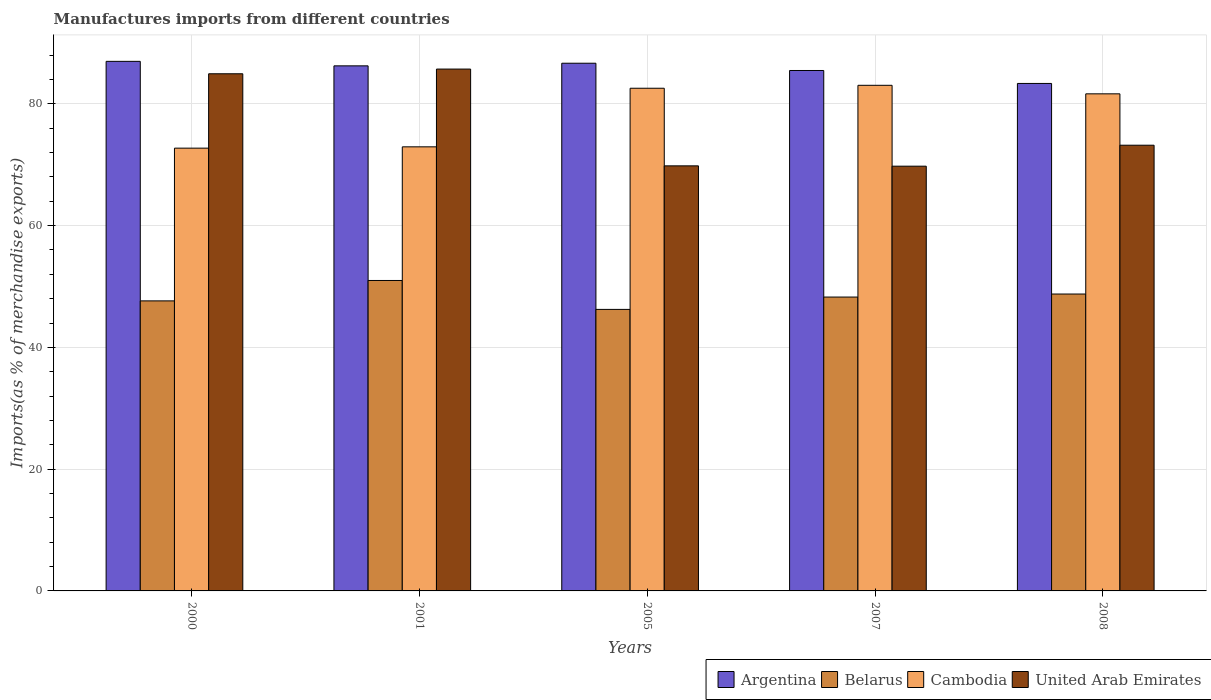How many different coloured bars are there?
Your answer should be very brief. 4. How many bars are there on the 5th tick from the left?
Keep it short and to the point. 4. What is the percentage of imports to different countries in Belarus in 2008?
Your answer should be very brief. 48.77. Across all years, what is the maximum percentage of imports to different countries in Argentina?
Your response must be concise. 86.98. Across all years, what is the minimum percentage of imports to different countries in Belarus?
Ensure brevity in your answer.  46.24. What is the total percentage of imports to different countries in Belarus in the graph?
Your answer should be compact. 241.91. What is the difference between the percentage of imports to different countries in Cambodia in 2001 and that in 2008?
Provide a succinct answer. -8.71. What is the difference between the percentage of imports to different countries in Argentina in 2000 and the percentage of imports to different countries in Cambodia in 2001?
Your response must be concise. 14.04. What is the average percentage of imports to different countries in Belarus per year?
Offer a terse response. 48.38. In the year 2001, what is the difference between the percentage of imports to different countries in Belarus and percentage of imports to different countries in United Arab Emirates?
Make the answer very short. -34.72. In how many years, is the percentage of imports to different countries in Belarus greater than 24 %?
Offer a terse response. 5. What is the ratio of the percentage of imports to different countries in Argentina in 2000 to that in 2007?
Provide a short and direct response. 1.02. What is the difference between the highest and the second highest percentage of imports to different countries in Belarus?
Provide a succinct answer. 2.23. What is the difference between the highest and the lowest percentage of imports to different countries in United Arab Emirates?
Make the answer very short. 15.95. Is it the case that in every year, the sum of the percentage of imports to different countries in Belarus and percentage of imports to different countries in United Arab Emirates is greater than the sum of percentage of imports to different countries in Cambodia and percentage of imports to different countries in Argentina?
Make the answer very short. No. What does the 4th bar from the left in 2007 represents?
Ensure brevity in your answer.  United Arab Emirates. What does the 1st bar from the right in 2000 represents?
Give a very brief answer. United Arab Emirates. How many bars are there?
Give a very brief answer. 20. Are all the bars in the graph horizontal?
Offer a very short reply. No. What is the difference between two consecutive major ticks on the Y-axis?
Make the answer very short. 20. Are the values on the major ticks of Y-axis written in scientific E-notation?
Your answer should be compact. No. Does the graph contain any zero values?
Provide a short and direct response. No. How many legend labels are there?
Provide a short and direct response. 4. How are the legend labels stacked?
Give a very brief answer. Horizontal. What is the title of the graph?
Your answer should be compact. Manufactures imports from different countries. What is the label or title of the X-axis?
Give a very brief answer. Years. What is the label or title of the Y-axis?
Provide a short and direct response. Imports(as % of merchandise exports). What is the Imports(as % of merchandise exports) of Argentina in 2000?
Give a very brief answer. 86.98. What is the Imports(as % of merchandise exports) in Belarus in 2000?
Your answer should be compact. 47.64. What is the Imports(as % of merchandise exports) in Cambodia in 2000?
Your answer should be very brief. 72.73. What is the Imports(as % of merchandise exports) in United Arab Emirates in 2000?
Ensure brevity in your answer.  84.94. What is the Imports(as % of merchandise exports) of Argentina in 2001?
Provide a short and direct response. 86.25. What is the Imports(as % of merchandise exports) in Belarus in 2001?
Your answer should be very brief. 50.99. What is the Imports(as % of merchandise exports) in Cambodia in 2001?
Offer a terse response. 72.94. What is the Imports(as % of merchandise exports) in United Arab Emirates in 2001?
Offer a terse response. 85.72. What is the Imports(as % of merchandise exports) in Argentina in 2005?
Provide a short and direct response. 86.68. What is the Imports(as % of merchandise exports) in Belarus in 2005?
Give a very brief answer. 46.24. What is the Imports(as % of merchandise exports) in Cambodia in 2005?
Keep it short and to the point. 82.57. What is the Imports(as % of merchandise exports) of United Arab Emirates in 2005?
Give a very brief answer. 69.82. What is the Imports(as % of merchandise exports) of Argentina in 2007?
Provide a short and direct response. 85.48. What is the Imports(as % of merchandise exports) of Belarus in 2007?
Offer a very short reply. 48.27. What is the Imports(as % of merchandise exports) in Cambodia in 2007?
Your answer should be compact. 83.05. What is the Imports(as % of merchandise exports) in United Arab Emirates in 2007?
Your answer should be compact. 69.77. What is the Imports(as % of merchandise exports) of Argentina in 2008?
Provide a short and direct response. 83.36. What is the Imports(as % of merchandise exports) of Belarus in 2008?
Your response must be concise. 48.77. What is the Imports(as % of merchandise exports) in Cambodia in 2008?
Ensure brevity in your answer.  81.65. What is the Imports(as % of merchandise exports) in United Arab Emirates in 2008?
Your answer should be very brief. 73.21. Across all years, what is the maximum Imports(as % of merchandise exports) of Argentina?
Offer a very short reply. 86.98. Across all years, what is the maximum Imports(as % of merchandise exports) of Belarus?
Offer a very short reply. 50.99. Across all years, what is the maximum Imports(as % of merchandise exports) in Cambodia?
Your response must be concise. 83.05. Across all years, what is the maximum Imports(as % of merchandise exports) of United Arab Emirates?
Provide a short and direct response. 85.72. Across all years, what is the minimum Imports(as % of merchandise exports) in Argentina?
Provide a succinct answer. 83.36. Across all years, what is the minimum Imports(as % of merchandise exports) of Belarus?
Offer a terse response. 46.24. Across all years, what is the minimum Imports(as % of merchandise exports) of Cambodia?
Offer a very short reply. 72.73. Across all years, what is the minimum Imports(as % of merchandise exports) in United Arab Emirates?
Your answer should be compact. 69.77. What is the total Imports(as % of merchandise exports) of Argentina in the graph?
Your answer should be compact. 428.74. What is the total Imports(as % of merchandise exports) in Belarus in the graph?
Provide a short and direct response. 241.91. What is the total Imports(as % of merchandise exports) of Cambodia in the graph?
Your answer should be compact. 392.94. What is the total Imports(as % of merchandise exports) of United Arab Emirates in the graph?
Ensure brevity in your answer.  383.45. What is the difference between the Imports(as % of merchandise exports) of Argentina in 2000 and that in 2001?
Offer a terse response. 0.74. What is the difference between the Imports(as % of merchandise exports) in Belarus in 2000 and that in 2001?
Offer a terse response. -3.35. What is the difference between the Imports(as % of merchandise exports) in Cambodia in 2000 and that in 2001?
Your response must be concise. -0.22. What is the difference between the Imports(as % of merchandise exports) in United Arab Emirates in 2000 and that in 2001?
Give a very brief answer. -0.77. What is the difference between the Imports(as % of merchandise exports) of Argentina in 2000 and that in 2005?
Your response must be concise. 0.31. What is the difference between the Imports(as % of merchandise exports) of Belarus in 2000 and that in 2005?
Give a very brief answer. 1.4. What is the difference between the Imports(as % of merchandise exports) in Cambodia in 2000 and that in 2005?
Ensure brevity in your answer.  -9.84. What is the difference between the Imports(as % of merchandise exports) in United Arab Emirates in 2000 and that in 2005?
Make the answer very short. 15.13. What is the difference between the Imports(as % of merchandise exports) in Argentina in 2000 and that in 2007?
Provide a succinct answer. 1.5. What is the difference between the Imports(as % of merchandise exports) of Belarus in 2000 and that in 2007?
Offer a terse response. -0.63. What is the difference between the Imports(as % of merchandise exports) of Cambodia in 2000 and that in 2007?
Offer a terse response. -10.32. What is the difference between the Imports(as % of merchandise exports) of United Arab Emirates in 2000 and that in 2007?
Offer a very short reply. 15.18. What is the difference between the Imports(as % of merchandise exports) in Argentina in 2000 and that in 2008?
Provide a short and direct response. 3.63. What is the difference between the Imports(as % of merchandise exports) in Belarus in 2000 and that in 2008?
Your answer should be compact. -1.13. What is the difference between the Imports(as % of merchandise exports) in Cambodia in 2000 and that in 2008?
Offer a very short reply. -8.92. What is the difference between the Imports(as % of merchandise exports) in United Arab Emirates in 2000 and that in 2008?
Offer a very short reply. 11.74. What is the difference between the Imports(as % of merchandise exports) in Argentina in 2001 and that in 2005?
Provide a succinct answer. -0.43. What is the difference between the Imports(as % of merchandise exports) of Belarus in 2001 and that in 2005?
Your answer should be compact. 4.75. What is the difference between the Imports(as % of merchandise exports) in Cambodia in 2001 and that in 2005?
Ensure brevity in your answer.  -9.62. What is the difference between the Imports(as % of merchandise exports) in United Arab Emirates in 2001 and that in 2005?
Offer a very short reply. 15.9. What is the difference between the Imports(as % of merchandise exports) in Argentina in 2001 and that in 2007?
Keep it short and to the point. 0.76. What is the difference between the Imports(as % of merchandise exports) in Belarus in 2001 and that in 2007?
Offer a very short reply. 2.73. What is the difference between the Imports(as % of merchandise exports) of Cambodia in 2001 and that in 2007?
Make the answer very short. -10.11. What is the difference between the Imports(as % of merchandise exports) in United Arab Emirates in 2001 and that in 2007?
Ensure brevity in your answer.  15.95. What is the difference between the Imports(as % of merchandise exports) of Argentina in 2001 and that in 2008?
Make the answer very short. 2.89. What is the difference between the Imports(as % of merchandise exports) in Belarus in 2001 and that in 2008?
Offer a very short reply. 2.23. What is the difference between the Imports(as % of merchandise exports) in Cambodia in 2001 and that in 2008?
Your response must be concise. -8.71. What is the difference between the Imports(as % of merchandise exports) in United Arab Emirates in 2001 and that in 2008?
Provide a short and direct response. 12.51. What is the difference between the Imports(as % of merchandise exports) of Argentina in 2005 and that in 2007?
Your response must be concise. 1.19. What is the difference between the Imports(as % of merchandise exports) of Belarus in 2005 and that in 2007?
Your response must be concise. -2.03. What is the difference between the Imports(as % of merchandise exports) in Cambodia in 2005 and that in 2007?
Make the answer very short. -0.48. What is the difference between the Imports(as % of merchandise exports) in United Arab Emirates in 2005 and that in 2007?
Ensure brevity in your answer.  0.05. What is the difference between the Imports(as % of merchandise exports) in Argentina in 2005 and that in 2008?
Your answer should be very brief. 3.32. What is the difference between the Imports(as % of merchandise exports) of Belarus in 2005 and that in 2008?
Give a very brief answer. -2.53. What is the difference between the Imports(as % of merchandise exports) in Cambodia in 2005 and that in 2008?
Provide a short and direct response. 0.92. What is the difference between the Imports(as % of merchandise exports) of United Arab Emirates in 2005 and that in 2008?
Offer a very short reply. -3.39. What is the difference between the Imports(as % of merchandise exports) in Argentina in 2007 and that in 2008?
Your answer should be compact. 2.13. What is the difference between the Imports(as % of merchandise exports) of Belarus in 2007 and that in 2008?
Keep it short and to the point. -0.5. What is the difference between the Imports(as % of merchandise exports) of Cambodia in 2007 and that in 2008?
Give a very brief answer. 1.4. What is the difference between the Imports(as % of merchandise exports) of United Arab Emirates in 2007 and that in 2008?
Offer a terse response. -3.44. What is the difference between the Imports(as % of merchandise exports) in Argentina in 2000 and the Imports(as % of merchandise exports) in Belarus in 2001?
Provide a short and direct response. 35.99. What is the difference between the Imports(as % of merchandise exports) of Argentina in 2000 and the Imports(as % of merchandise exports) of Cambodia in 2001?
Your answer should be very brief. 14.04. What is the difference between the Imports(as % of merchandise exports) of Argentina in 2000 and the Imports(as % of merchandise exports) of United Arab Emirates in 2001?
Keep it short and to the point. 1.27. What is the difference between the Imports(as % of merchandise exports) of Belarus in 2000 and the Imports(as % of merchandise exports) of Cambodia in 2001?
Provide a short and direct response. -25.3. What is the difference between the Imports(as % of merchandise exports) of Belarus in 2000 and the Imports(as % of merchandise exports) of United Arab Emirates in 2001?
Make the answer very short. -38.07. What is the difference between the Imports(as % of merchandise exports) of Cambodia in 2000 and the Imports(as % of merchandise exports) of United Arab Emirates in 2001?
Offer a very short reply. -12.99. What is the difference between the Imports(as % of merchandise exports) of Argentina in 2000 and the Imports(as % of merchandise exports) of Belarus in 2005?
Provide a short and direct response. 40.74. What is the difference between the Imports(as % of merchandise exports) of Argentina in 2000 and the Imports(as % of merchandise exports) of Cambodia in 2005?
Give a very brief answer. 4.42. What is the difference between the Imports(as % of merchandise exports) of Argentina in 2000 and the Imports(as % of merchandise exports) of United Arab Emirates in 2005?
Your response must be concise. 17.16. What is the difference between the Imports(as % of merchandise exports) of Belarus in 2000 and the Imports(as % of merchandise exports) of Cambodia in 2005?
Provide a succinct answer. -34.93. What is the difference between the Imports(as % of merchandise exports) of Belarus in 2000 and the Imports(as % of merchandise exports) of United Arab Emirates in 2005?
Offer a terse response. -22.18. What is the difference between the Imports(as % of merchandise exports) of Cambodia in 2000 and the Imports(as % of merchandise exports) of United Arab Emirates in 2005?
Your answer should be very brief. 2.91. What is the difference between the Imports(as % of merchandise exports) of Argentina in 2000 and the Imports(as % of merchandise exports) of Belarus in 2007?
Make the answer very short. 38.72. What is the difference between the Imports(as % of merchandise exports) in Argentina in 2000 and the Imports(as % of merchandise exports) in Cambodia in 2007?
Your answer should be very brief. 3.93. What is the difference between the Imports(as % of merchandise exports) of Argentina in 2000 and the Imports(as % of merchandise exports) of United Arab Emirates in 2007?
Keep it short and to the point. 17.22. What is the difference between the Imports(as % of merchandise exports) in Belarus in 2000 and the Imports(as % of merchandise exports) in Cambodia in 2007?
Provide a short and direct response. -35.41. What is the difference between the Imports(as % of merchandise exports) in Belarus in 2000 and the Imports(as % of merchandise exports) in United Arab Emirates in 2007?
Your answer should be compact. -22.12. What is the difference between the Imports(as % of merchandise exports) of Cambodia in 2000 and the Imports(as % of merchandise exports) of United Arab Emirates in 2007?
Provide a succinct answer. 2.96. What is the difference between the Imports(as % of merchandise exports) in Argentina in 2000 and the Imports(as % of merchandise exports) in Belarus in 2008?
Your answer should be very brief. 38.22. What is the difference between the Imports(as % of merchandise exports) in Argentina in 2000 and the Imports(as % of merchandise exports) in Cambodia in 2008?
Your answer should be very brief. 5.33. What is the difference between the Imports(as % of merchandise exports) in Argentina in 2000 and the Imports(as % of merchandise exports) in United Arab Emirates in 2008?
Give a very brief answer. 13.78. What is the difference between the Imports(as % of merchandise exports) in Belarus in 2000 and the Imports(as % of merchandise exports) in Cambodia in 2008?
Ensure brevity in your answer.  -34.01. What is the difference between the Imports(as % of merchandise exports) of Belarus in 2000 and the Imports(as % of merchandise exports) of United Arab Emirates in 2008?
Offer a terse response. -25.57. What is the difference between the Imports(as % of merchandise exports) in Cambodia in 2000 and the Imports(as % of merchandise exports) in United Arab Emirates in 2008?
Your answer should be very brief. -0.48. What is the difference between the Imports(as % of merchandise exports) in Argentina in 2001 and the Imports(as % of merchandise exports) in Belarus in 2005?
Keep it short and to the point. 40. What is the difference between the Imports(as % of merchandise exports) of Argentina in 2001 and the Imports(as % of merchandise exports) of Cambodia in 2005?
Your answer should be very brief. 3.68. What is the difference between the Imports(as % of merchandise exports) in Argentina in 2001 and the Imports(as % of merchandise exports) in United Arab Emirates in 2005?
Your response must be concise. 16.43. What is the difference between the Imports(as % of merchandise exports) in Belarus in 2001 and the Imports(as % of merchandise exports) in Cambodia in 2005?
Offer a terse response. -31.57. What is the difference between the Imports(as % of merchandise exports) of Belarus in 2001 and the Imports(as % of merchandise exports) of United Arab Emirates in 2005?
Make the answer very short. -18.83. What is the difference between the Imports(as % of merchandise exports) in Cambodia in 2001 and the Imports(as % of merchandise exports) in United Arab Emirates in 2005?
Your answer should be compact. 3.12. What is the difference between the Imports(as % of merchandise exports) in Argentina in 2001 and the Imports(as % of merchandise exports) in Belarus in 2007?
Make the answer very short. 37.98. What is the difference between the Imports(as % of merchandise exports) of Argentina in 2001 and the Imports(as % of merchandise exports) of Cambodia in 2007?
Your response must be concise. 3.2. What is the difference between the Imports(as % of merchandise exports) of Argentina in 2001 and the Imports(as % of merchandise exports) of United Arab Emirates in 2007?
Make the answer very short. 16.48. What is the difference between the Imports(as % of merchandise exports) in Belarus in 2001 and the Imports(as % of merchandise exports) in Cambodia in 2007?
Offer a terse response. -32.06. What is the difference between the Imports(as % of merchandise exports) of Belarus in 2001 and the Imports(as % of merchandise exports) of United Arab Emirates in 2007?
Offer a terse response. -18.77. What is the difference between the Imports(as % of merchandise exports) of Cambodia in 2001 and the Imports(as % of merchandise exports) of United Arab Emirates in 2007?
Provide a short and direct response. 3.18. What is the difference between the Imports(as % of merchandise exports) of Argentina in 2001 and the Imports(as % of merchandise exports) of Belarus in 2008?
Provide a succinct answer. 37.48. What is the difference between the Imports(as % of merchandise exports) of Argentina in 2001 and the Imports(as % of merchandise exports) of Cambodia in 2008?
Make the answer very short. 4.6. What is the difference between the Imports(as % of merchandise exports) in Argentina in 2001 and the Imports(as % of merchandise exports) in United Arab Emirates in 2008?
Your answer should be very brief. 13.04. What is the difference between the Imports(as % of merchandise exports) of Belarus in 2001 and the Imports(as % of merchandise exports) of Cambodia in 2008?
Your response must be concise. -30.66. What is the difference between the Imports(as % of merchandise exports) in Belarus in 2001 and the Imports(as % of merchandise exports) in United Arab Emirates in 2008?
Keep it short and to the point. -22.22. What is the difference between the Imports(as % of merchandise exports) in Cambodia in 2001 and the Imports(as % of merchandise exports) in United Arab Emirates in 2008?
Your answer should be very brief. -0.27. What is the difference between the Imports(as % of merchandise exports) of Argentina in 2005 and the Imports(as % of merchandise exports) of Belarus in 2007?
Your answer should be compact. 38.41. What is the difference between the Imports(as % of merchandise exports) in Argentina in 2005 and the Imports(as % of merchandise exports) in Cambodia in 2007?
Your answer should be very brief. 3.62. What is the difference between the Imports(as % of merchandise exports) in Argentina in 2005 and the Imports(as % of merchandise exports) in United Arab Emirates in 2007?
Ensure brevity in your answer.  16.91. What is the difference between the Imports(as % of merchandise exports) of Belarus in 2005 and the Imports(as % of merchandise exports) of Cambodia in 2007?
Your answer should be very brief. -36.81. What is the difference between the Imports(as % of merchandise exports) in Belarus in 2005 and the Imports(as % of merchandise exports) in United Arab Emirates in 2007?
Your answer should be compact. -23.53. What is the difference between the Imports(as % of merchandise exports) in Cambodia in 2005 and the Imports(as % of merchandise exports) in United Arab Emirates in 2007?
Give a very brief answer. 12.8. What is the difference between the Imports(as % of merchandise exports) in Argentina in 2005 and the Imports(as % of merchandise exports) in Belarus in 2008?
Keep it short and to the point. 37.91. What is the difference between the Imports(as % of merchandise exports) of Argentina in 2005 and the Imports(as % of merchandise exports) of Cambodia in 2008?
Your answer should be compact. 5.03. What is the difference between the Imports(as % of merchandise exports) of Argentina in 2005 and the Imports(as % of merchandise exports) of United Arab Emirates in 2008?
Ensure brevity in your answer.  13.47. What is the difference between the Imports(as % of merchandise exports) in Belarus in 2005 and the Imports(as % of merchandise exports) in Cambodia in 2008?
Provide a short and direct response. -35.41. What is the difference between the Imports(as % of merchandise exports) in Belarus in 2005 and the Imports(as % of merchandise exports) in United Arab Emirates in 2008?
Your response must be concise. -26.97. What is the difference between the Imports(as % of merchandise exports) of Cambodia in 2005 and the Imports(as % of merchandise exports) of United Arab Emirates in 2008?
Provide a succinct answer. 9.36. What is the difference between the Imports(as % of merchandise exports) in Argentina in 2007 and the Imports(as % of merchandise exports) in Belarus in 2008?
Your answer should be compact. 36.72. What is the difference between the Imports(as % of merchandise exports) of Argentina in 2007 and the Imports(as % of merchandise exports) of Cambodia in 2008?
Make the answer very short. 3.83. What is the difference between the Imports(as % of merchandise exports) in Argentina in 2007 and the Imports(as % of merchandise exports) in United Arab Emirates in 2008?
Make the answer very short. 12.27. What is the difference between the Imports(as % of merchandise exports) of Belarus in 2007 and the Imports(as % of merchandise exports) of Cambodia in 2008?
Offer a terse response. -33.38. What is the difference between the Imports(as % of merchandise exports) of Belarus in 2007 and the Imports(as % of merchandise exports) of United Arab Emirates in 2008?
Offer a very short reply. -24.94. What is the difference between the Imports(as % of merchandise exports) in Cambodia in 2007 and the Imports(as % of merchandise exports) in United Arab Emirates in 2008?
Keep it short and to the point. 9.84. What is the average Imports(as % of merchandise exports) of Argentina per year?
Provide a succinct answer. 85.75. What is the average Imports(as % of merchandise exports) in Belarus per year?
Your answer should be compact. 48.38. What is the average Imports(as % of merchandise exports) of Cambodia per year?
Provide a succinct answer. 78.59. What is the average Imports(as % of merchandise exports) of United Arab Emirates per year?
Ensure brevity in your answer.  76.69. In the year 2000, what is the difference between the Imports(as % of merchandise exports) of Argentina and Imports(as % of merchandise exports) of Belarus?
Keep it short and to the point. 39.34. In the year 2000, what is the difference between the Imports(as % of merchandise exports) in Argentina and Imports(as % of merchandise exports) in Cambodia?
Offer a very short reply. 14.26. In the year 2000, what is the difference between the Imports(as % of merchandise exports) in Argentina and Imports(as % of merchandise exports) in United Arab Emirates?
Keep it short and to the point. 2.04. In the year 2000, what is the difference between the Imports(as % of merchandise exports) of Belarus and Imports(as % of merchandise exports) of Cambodia?
Provide a succinct answer. -25.09. In the year 2000, what is the difference between the Imports(as % of merchandise exports) in Belarus and Imports(as % of merchandise exports) in United Arab Emirates?
Make the answer very short. -37.3. In the year 2000, what is the difference between the Imports(as % of merchandise exports) of Cambodia and Imports(as % of merchandise exports) of United Arab Emirates?
Ensure brevity in your answer.  -12.22. In the year 2001, what is the difference between the Imports(as % of merchandise exports) in Argentina and Imports(as % of merchandise exports) in Belarus?
Your answer should be compact. 35.25. In the year 2001, what is the difference between the Imports(as % of merchandise exports) of Argentina and Imports(as % of merchandise exports) of Cambodia?
Your answer should be compact. 13.3. In the year 2001, what is the difference between the Imports(as % of merchandise exports) in Argentina and Imports(as % of merchandise exports) in United Arab Emirates?
Your answer should be very brief. 0.53. In the year 2001, what is the difference between the Imports(as % of merchandise exports) of Belarus and Imports(as % of merchandise exports) of Cambodia?
Keep it short and to the point. -21.95. In the year 2001, what is the difference between the Imports(as % of merchandise exports) in Belarus and Imports(as % of merchandise exports) in United Arab Emirates?
Your answer should be compact. -34.72. In the year 2001, what is the difference between the Imports(as % of merchandise exports) in Cambodia and Imports(as % of merchandise exports) in United Arab Emirates?
Your answer should be compact. -12.77. In the year 2005, what is the difference between the Imports(as % of merchandise exports) of Argentina and Imports(as % of merchandise exports) of Belarus?
Your response must be concise. 40.43. In the year 2005, what is the difference between the Imports(as % of merchandise exports) of Argentina and Imports(as % of merchandise exports) of Cambodia?
Offer a terse response. 4.11. In the year 2005, what is the difference between the Imports(as % of merchandise exports) of Argentina and Imports(as % of merchandise exports) of United Arab Emirates?
Your response must be concise. 16.86. In the year 2005, what is the difference between the Imports(as % of merchandise exports) of Belarus and Imports(as % of merchandise exports) of Cambodia?
Ensure brevity in your answer.  -36.33. In the year 2005, what is the difference between the Imports(as % of merchandise exports) of Belarus and Imports(as % of merchandise exports) of United Arab Emirates?
Provide a short and direct response. -23.58. In the year 2005, what is the difference between the Imports(as % of merchandise exports) of Cambodia and Imports(as % of merchandise exports) of United Arab Emirates?
Your answer should be compact. 12.75. In the year 2007, what is the difference between the Imports(as % of merchandise exports) in Argentina and Imports(as % of merchandise exports) in Belarus?
Provide a succinct answer. 37.22. In the year 2007, what is the difference between the Imports(as % of merchandise exports) in Argentina and Imports(as % of merchandise exports) in Cambodia?
Keep it short and to the point. 2.43. In the year 2007, what is the difference between the Imports(as % of merchandise exports) of Argentina and Imports(as % of merchandise exports) of United Arab Emirates?
Ensure brevity in your answer.  15.72. In the year 2007, what is the difference between the Imports(as % of merchandise exports) of Belarus and Imports(as % of merchandise exports) of Cambodia?
Your answer should be compact. -34.78. In the year 2007, what is the difference between the Imports(as % of merchandise exports) in Belarus and Imports(as % of merchandise exports) in United Arab Emirates?
Your answer should be very brief. -21.5. In the year 2007, what is the difference between the Imports(as % of merchandise exports) in Cambodia and Imports(as % of merchandise exports) in United Arab Emirates?
Your answer should be very brief. 13.28. In the year 2008, what is the difference between the Imports(as % of merchandise exports) of Argentina and Imports(as % of merchandise exports) of Belarus?
Offer a terse response. 34.59. In the year 2008, what is the difference between the Imports(as % of merchandise exports) of Argentina and Imports(as % of merchandise exports) of Cambodia?
Keep it short and to the point. 1.71. In the year 2008, what is the difference between the Imports(as % of merchandise exports) of Argentina and Imports(as % of merchandise exports) of United Arab Emirates?
Your answer should be very brief. 10.15. In the year 2008, what is the difference between the Imports(as % of merchandise exports) of Belarus and Imports(as % of merchandise exports) of Cambodia?
Your response must be concise. -32.88. In the year 2008, what is the difference between the Imports(as % of merchandise exports) of Belarus and Imports(as % of merchandise exports) of United Arab Emirates?
Provide a short and direct response. -24.44. In the year 2008, what is the difference between the Imports(as % of merchandise exports) in Cambodia and Imports(as % of merchandise exports) in United Arab Emirates?
Offer a very short reply. 8.44. What is the ratio of the Imports(as % of merchandise exports) of Argentina in 2000 to that in 2001?
Offer a terse response. 1.01. What is the ratio of the Imports(as % of merchandise exports) in Belarus in 2000 to that in 2001?
Provide a succinct answer. 0.93. What is the ratio of the Imports(as % of merchandise exports) of Cambodia in 2000 to that in 2001?
Provide a short and direct response. 1. What is the ratio of the Imports(as % of merchandise exports) in United Arab Emirates in 2000 to that in 2001?
Offer a very short reply. 0.99. What is the ratio of the Imports(as % of merchandise exports) in Belarus in 2000 to that in 2005?
Your answer should be very brief. 1.03. What is the ratio of the Imports(as % of merchandise exports) of Cambodia in 2000 to that in 2005?
Ensure brevity in your answer.  0.88. What is the ratio of the Imports(as % of merchandise exports) in United Arab Emirates in 2000 to that in 2005?
Ensure brevity in your answer.  1.22. What is the ratio of the Imports(as % of merchandise exports) in Argentina in 2000 to that in 2007?
Keep it short and to the point. 1.02. What is the ratio of the Imports(as % of merchandise exports) of Cambodia in 2000 to that in 2007?
Provide a short and direct response. 0.88. What is the ratio of the Imports(as % of merchandise exports) in United Arab Emirates in 2000 to that in 2007?
Keep it short and to the point. 1.22. What is the ratio of the Imports(as % of merchandise exports) in Argentina in 2000 to that in 2008?
Keep it short and to the point. 1.04. What is the ratio of the Imports(as % of merchandise exports) in Belarus in 2000 to that in 2008?
Your answer should be very brief. 0.98. What is the ratio of the Imports(as % of merchandise exports) of Cambodia in 2000 to that in 2008?
Your response must be concise. 0.89. What is the ratio of the Imports(as % of merchandise exports) of United Arab Emirates in 2000 to that in 2008?
Keep it short and to the point. 1.16. What is the ratio of the Imports(as % of merchandise exports) in Argentina in 2001 to that in 2005?
Provide a short and direct response. 0.99. What is the ratio of the Imports(as % of merchandise exports) in Belarus in 2001 to that in 2005?
Give a very brief answer. 1.1. What is the ratio of the Imports(as % of merchandise exports) of Cambodia in 2001 to that in 2005?
Make the answer very short. 0.88. What is the ratio of the Imports(as % of merchandise exports) of United Arab Emirates in 2001 to that in 2005?
Ensure brevity in your answer.  1.23. What is the ratio of the Imports(as % of merchandise exports) in Argentina in 2001 to that in 2007?
Offer a terse response. 1.01. What is the ratio of the Imports(as % of merchandise exports) of Belarus in 2001 to that in 2007?
Ensure brevity in your answer.  1.06. What is the ratio of the Imports(as % of merchandise exports) of Cambodia in 2001 to that in 2007?
Give a very brief answer. 0.88. What is the ratio of the Imports(as % of merchandise exports) of United Arab Emirates in 2001 to that in 2007?
Your answer should be compact. 1.23. What is the ratio of the Imports(as % of merchandise exports) in Argentina in 2001 to that in 2008?
Your answer should be compact. 1.03. What is the ratio of the Imports(as % of merchandise exports) in Belarus in 2001 to that in 2008?
Your response must be concise. 1.05. What is the ratio of the Imports(as % of merchandise exports) of Cambodia in 2001 to that in 2008?
Offer a very short reply. 0.89. What is the ratio of the Imports(as % of merchandise exports) in United Arab Emirates in 2001 to that in 2008?
Provide a succinct answer. 1.17. What is the ratio of the Imports(as % of merchandise exports) in Argentina in 2005 to that in 2007?
Offer a terse response. 1.01. What is the ratio of the Imports(as % of merchandise exports) in Belarus in 2005 to that in 2007?
Ensure brevity in your answer.  0.96. What is the ratio of the Imports(as % of merchandise exports) of Cambodia in 2005 to that in 2007?
Provide a short and direct response. 0.99. What is the ratio of the Imports(as % of merchandise exports) of Argentina in 2005 to that in 2008?
Offer a very short reply. 1.04. What is the ratio of the Imports(as % of merchandise exports) in Belarus in 2005 to that in 2008?
Offer a terse response. 0.95. What is the ratio of the Imports(as % of merchandise exports) of Cambodia in 2005 to that in 2008?
Make the answer very short. 1.01. What is the ratio of the Imports(as % of merchandise exports) of United Arab Emirates in 2005 to that in 2008?
Offer a terse response. 0.95. What is the ratio of the Imports(as % of merchandise exports) in Argentina in 2007 to that in 2008?
Keep it short and to the point. 1.03. What is the ratio of the Imports(as % of merchandise exports) in Belarus in 2007 to that in 2008?
Offer a very short reply. 0.99. What is the ratio of the Imports(as % of merchandise exports) in Cambodia in 2007 to that in 2008?
Provide a succinct answer. 1.02. What is the ratio of the Imports(as % of merchandise exports) of United Arab Emirates in 2007 to that in 2008?
Your response must be concise. 0.95. What is the difference between the highest and the second highest Imports(as % of merchandise exports) of Argentina?
Provide a short and direct response. 0.31. What is the difference between the highest and the second highest Imports(as % of merchandise exports) in Belarus?
Provide a succinct answer. 2.23. What is the difference between the highest and the second highest Imports(as % of merchandise exports) in Cambodia?
Your answer should be very brief. 0.48. What is the difference between the highest and the second highest Imports(as % of merchandise exports) of United Arab Emirates?
Your answer should be compact. 0.77. What is the difference between the highest and the lowest Imports(as % of merchandise exports) in Argentina?
Ensure brevity in your answer.  3.63. What is the difference between the highest and the lowest Imports(as % of merchandise exports) of Belarus?
Your answer should be very brief. 4.75. What is the difference between the highest and the lowest Imports(as % of merchandise exports) of Cambodia?
Offer a terse response. 10.32. What is the difference between the highest and the lowest Imports(as % of merchandise exports) in United Arab Emirates?
Your answer should be compact. 15.95. 